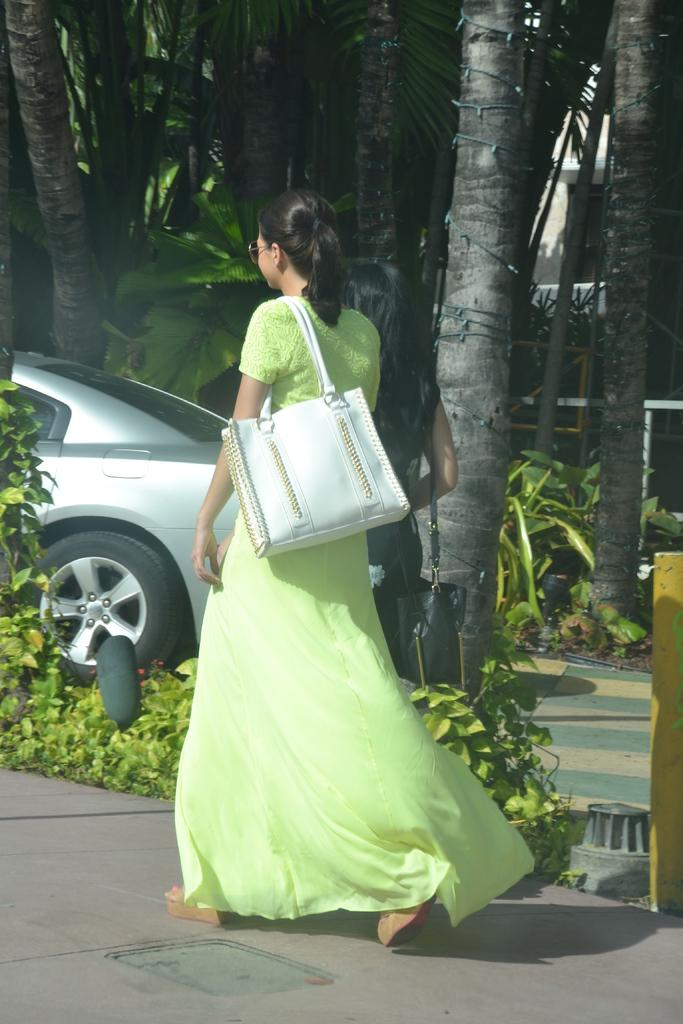Who is present in the image? There is a woman in the image. What is the woman wearing? The woman is wearing a green dress. What is the woman doing in the image? The woman is standing. What is the woman holding in the image? The woman is carrying a bag. What can be seen in the background of the image? There are trees, plants, and a vehicle in the background of the image. What type of meat is the woman preparing in the image? There is no meat or any indication of food preparation in the image. 